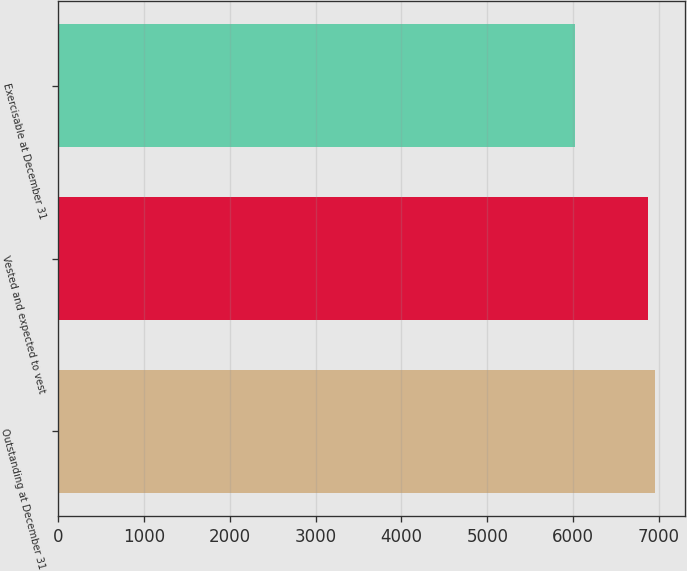Convert chart. <chart><loc_0><loc_0><loc_500><loc_500><bar_chart><fcel>Outstanding at December 31<fcel>Vested and expected to vest<fcel>Exercisable at December 31<nl><fcel>6958.8<fcel>6872<fcel>6017<nl></chart> 